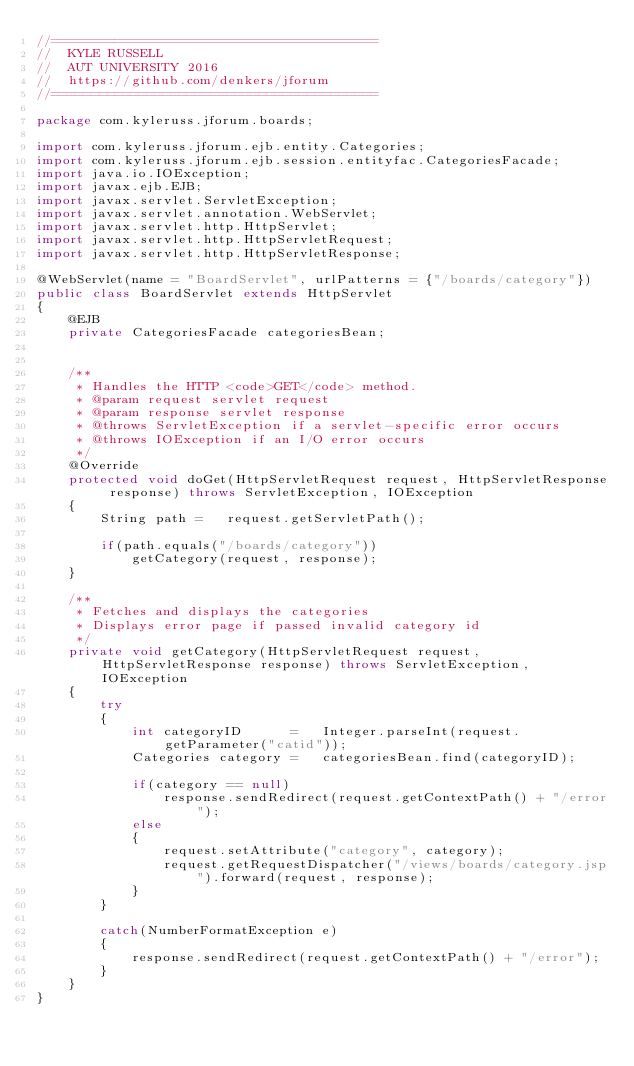<code> <loc_0><loc_0><loc_500><loc_500><_Java_>//=========================================
//  KYLE RUSSELL
//  AUT UNIVERSITY 2016
//  https://github.com/denkers/jforum
//=========================================

package com.kyleruss.jforum.boards;

import com.kyleruss.jforum.ejb.entity.Categories;
import com.kyleruss.jforum.ejb.session.entityfac.CategoriesFacade;
import java.io.IOException;
import javax.ejb.EJB;
import javax.servlet.ServletException;
import javax.servlet.annotation.WebServlet;
import javax.servlet.http.HttpServlet;
import javax.servlet.http.HttpServletRequest;
import javax.servlet.http.HttpServletResponse;

@WebServlet(name = "BoardServlet", urlPatterns = {"/boards/category"})
public class BoardServlet extends HttpServlet 
{
    @EJB
    private CategoriesFacade categoriesBean;
    

    /**
     * Handles the HTTP <code>GET</code> method.
     * @param request servlet request
     * @param response servlet response
     * @throws ServletException if a servlet-specific error occurs
     * @throws IOException if an I/O error occurs
     */
    @Override
    protected void doGet(HttpServletRequest request, HttpServletResponse response) throws ServletException, IOException 
    {
        String path =   request.getServletPath();
        
        if(path.equals("/boards/category"))
            getCategory(request, response);
    }
    
    /**
     * Fetches and displays the categories
     * Displays error page if passed invalid category id
     */
    private void getCategory(HttpServletRequest request, HttpServletResponse response) throws ServletException, IOException 
    {
        try
        {
            int categoryID      =   Integer.parseInt(request.getParameter("catid"));
            Categories category =   categoriesBean.find(categoryID);
            
            if(category == null)
                response.sendRedirect(request.getContextPath() + "/error");
            else
            {
                request.setAttribute("category", category);
                request.getRequestDispatcher("/views/boards/category.jsp").forward(request, response);
            }
        }
        
        catch(NumberFormatException e)
        {
            response.sendRedirect(request.getContextPath() + "/error");
        }
    }
}
</code> 